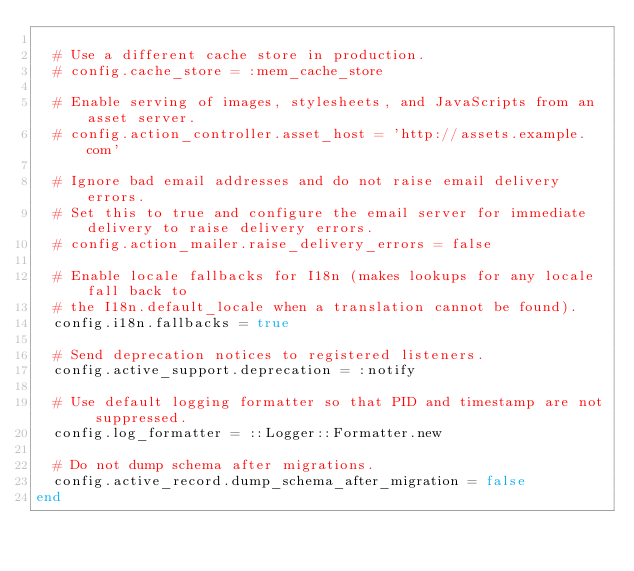Convert code to text. <code><loc_0><loc_0><loc_500><loc_500><_Ruby_>
  # Use a different cache store in production.
  # config.cache_store = :mem_cache_store

  # Enable serving of images, stylesheets, and JavaScripts from an asset server.
  # config.action_controller.asset_host = 'http://assets.example.com'

  # Ignore bad email addresses and do not raise email delivery errors.
  # Set this to true and configure the email server for immediate delivery to raise delivery errors.
  # config.action_mailer.raise_delivery_errors = false

  # Enable locale fallbacks for I18n (makes lookups for any locale fall back to
  # the I18n.default_locale when a translation cannot be found).
  config.i18n.fallbacks = true

  # Send deprecation notices to registered listeners.
  config.active_support.deprecation = :notify

  # Use default logging formatter so that PID and timestamp are not suppressed.
  config.log_formatter = ::Logger::Formatter.new

  # Do not dump schema after migrations.
  config.active_record.dump_schema_after_migration = false
end
</code> 